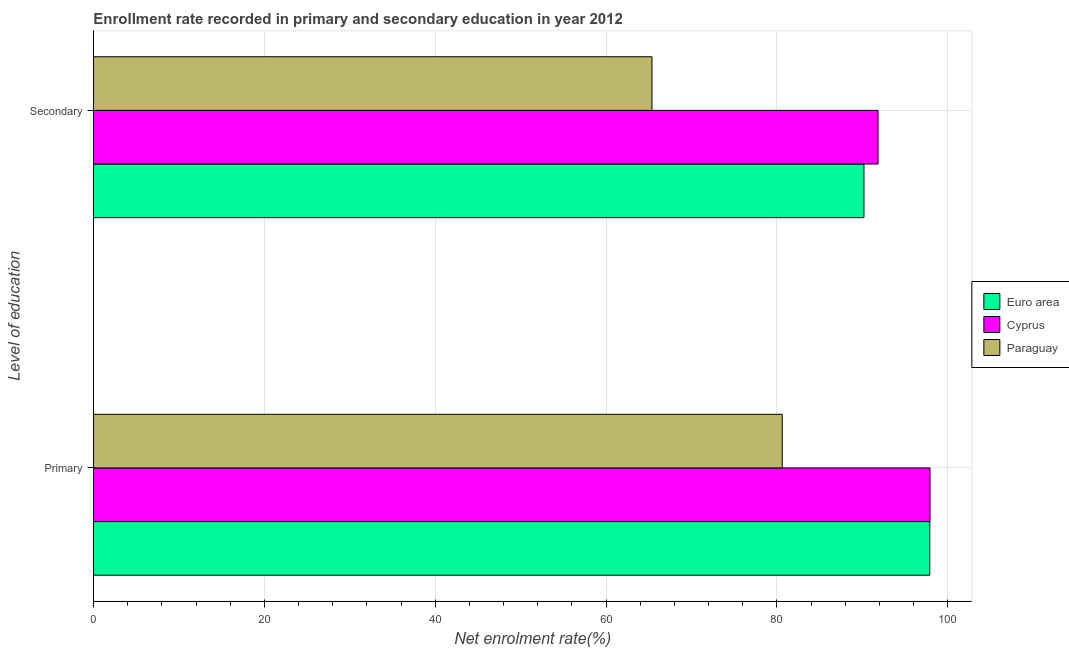Are the number of bars on each tick of the Y-axis equal?
Provide a succinct answer. Yes. How many bars are there on the 2nd tick from the top?
Your response must be concise. 3. What is the label of the 1st group of bars from the top?
Make the answer very short. Secondary. What is the enrollment rate in secondary education in Cyprus?
Provide a short and direct response. 91.83. Across all countries, what is the maximum enrollment rate in secondary education?
Keep it short and to the point. 91.83. Across all countries, what is the minimum enrollment rate in secondary education?
Ensure brevity in your answer.  65.37. In which country was the enrollment rate in secondary education maximum?
Make the answer very short. Cyprus. In which country was the enrollment rate in secondary education minimum?
Your answer should be compact. Paraguay. What is the total enrollment rate in primary education in the graph?
Provide a succinct answer. 276.42. What is the difference between the enrollment rate in secondary education in Paraguay and that in Cyprus?
Provide a succinct answer. -26.46. What is the difference between the enrollment rate in primary education in Euro area and the enrollment rate in secondary education in Paraguay?
Make the answer very short. 32.52. What is the average enrollment rate in primary education per country?
Provide a succinct answer. 92.14. What is the difference between the enrollment rate in primary education and enrollment rate in secondary education in Cyprus?
Provide a succinct answer. 6.08. In how many countries, is the enrollment rate in secondary education greater than 16 %?
Offer a terse response. 3. What is the ratio of the enrollment rate in primary education in Cyprus to that in Euro area?
Provide a succinct answer. 1. In how many countries, is the enrollment rate in primary education greater than the average enrollment rate in primary education taken over all countries?
Ensure brevity in your answer.  2. What does the 1st bar from the top in Secondary represents?
Keep it short and to the point. Paraguay. What does the 1st bar from the bottom in Secondary represents?
Your response must be concise. Euro area. How many bars are there?
Your response must be concise. 6. What is the difference between two consecutive major ticks on the X-axis?
Your answer should be very brief. 20. Are the values on the major ticks of X-axis written in scientific E-notation?
Provide a short and direct response. No. Where does the legend appear in the graph?
Ensure brevity in your answer.  Center right. How are the legend labels stacked?
Your answer should be compact. Vertical. What is the title of the graph?
Your response must be concise. Enrollment rate recorded in primary and secondary education in year 2012. Does "Ecuador" appear as one of the legend labels in the graph?
Ensure brevity in your answer.  No. What is the label or title of the X-axis?
Offer a very short reply. Net enrolment rate(%). What is the label or title of the Y-axis?
Offer a terse response. Level of education. What is the Net enrolment rate(%) of Euro area in Primary?
Keep it short and to the point. 97.89. What is the Net enrolment rate(%) of Cyprus in Primary?
Offer a very short reply. 97.91. What is the Net enrolment rate(%) in Paraguay in Primary?
Provide a succinct answer. 80.62. What is the Net enrolment rate(%) in Euro area in Secondary?
Make the answer very short. 90.18. What is the Net enrolment rate(%) of Cyprus in Secondary?
Ensure brevity in your answer.  91.83. What is the Net enrolment rate(%) in Paraguay in Secondary?
Ensure brevity in your answer.  65.37. Across all Level of education, what is the maximum Net enrolment rate(%) in Euro area?
Your answer should be very brief. 97.89. Across all Level of education, what is the maximum Net enrolment rate(%) in Cyprus?
Make the answer very short. 97.91. Across all Level of education, what is the maximum Net enrolment rate(%) in Paraguay?
Provide a succinct answer. 80.62. Across all Level of education, what is the minimum Net enrolment rate(%) of Euro area?
Provide a short and direct response. 90.18. Across all Level of education, what is the minimum Net enrolment rate(%) in Cyprus?
Provide a succinct answer. 91.83. Across all Level of education, what is the minimum Net enrolment rate(%) in Paraguay?
Provide a short and direct response. 65.37. What is the total Net enrolment rate(%) in Euro area in the graph?
Your answer should be compact. 188.07. What is the total Net enrolment rate(%) in Cyprus in the graph?
Offer a very short reply. 189.74. What is the total Net enrolment rate(%) in Paraguay in the graph?
Offer a terse response. 145.99. What is the difference between the Net enrolment rate(%) of Euro area in Primary and that in Secondary?
Provide a short and direct response. 7.7. What is the difference between the Net enrolment rate(%) in Cyprus in Primary and that in Secondary?
Make the answer very short. 6.08. What is the difference between the Net enrolment rate(%) in Paraguay in Primary and that in Secondary?
Your answer should be compact. 15.25. What is the difference between the Net enrolment rate(%) in Euro area in Primary and the Net enrolment rate(%) in Cyprus in Secondary?
Offer a very short reply. 6.06. What is the difference between the Net enrolment rate(%) of Euro area in Primary and the Net enrolment rate(%) of Paraguay in Secondary?
Your response must be concise. 32.52. What is the difference between the Net enrolment rate(%) in Cyprus in Primary and the Net enrolment rate(%) in Paraguay in Secondary?
Your answer should be compact. 32.54. What is the average Net enrolment rate(%) of Euro area per Level of education?
Offer a very short reply. 94.04. What is the average Net enrolment rate(%) of Cyprus per Level of education?
Give a very brief answer. 94.87. What is the average Net enrolment rate(%) in Paraguay per Level of education?
Make the answer very short. 72.99. What is the difference between the Net enrolment rate(%) of Euro area and Net enrolment rate(%) of Cyprus in Primary?
Keep it short and to the point. -0.02. What is the difference between the Net enrolment rate(%) of Euro area and Net enrolment rate(%) of Paraguay in Primary?
Provide a succinct answer. 17.27. What is the difference between the Net enrolment rate(%) in Cyprus and Net enrolment rate(%) in Paraguay in Primary?
Your answer should be very brief. 17.29. What is the difference between the Net enrolment rate(%) of Euro area and Net enrolment rate(%) of Cyprus in Secondary?
Offer a very short reply. -1.65. What is the difference between the Net enrolment rate(%) in Euro area and Net enrolment rate(%) in Paraguay in Secondary?
Make the answer very short. 24.81. What is the difference between the Net enrolment rate(%) of Cyprus and Net enrolment rate(%) of Paraguay in Secondary?
Provide a short and direct response. 26.46. What is the ratio of the Net enrolment rate(%) of Euro area in Primary to that in Secondary?
Your response must be concise. 1.09. What is the ratio of the Net enrolment rate(%) of Cyprus in Primary to that in Secondary?
Your answer should be compact. 1.07. What is the ratio of the Net enrolment rate(%) of Paraguay in Primary to that in Secondary?
Give a very brief answer. 1.23. What is the difference between the highest and the second highest Net enrolment rate(%) in Euro area?
Make the answer very short. 7.7. What is the difference between the highest and the second highest Net enrolment rate(%) of Cyprus?
Provide a succinct answer. 6.08. What is the difference between the highest and the second highest Net enrolment rate(%) of Paraguay?
Offer a terse response. 15.25. What is the difference between the highest and the lowest Net enrolment rate(%) of Euro area?
Ensure brevity in your answer.  7.7. What is the difference between the highest and the lowest Net enrolment rate(%) of Cyprus?
Provide a short and direct response. 6.08. What is the difference between the highest and the lowest Net enrolment rate(%) of Paraguay?
Ensure brevity in your answer.  15.25. 